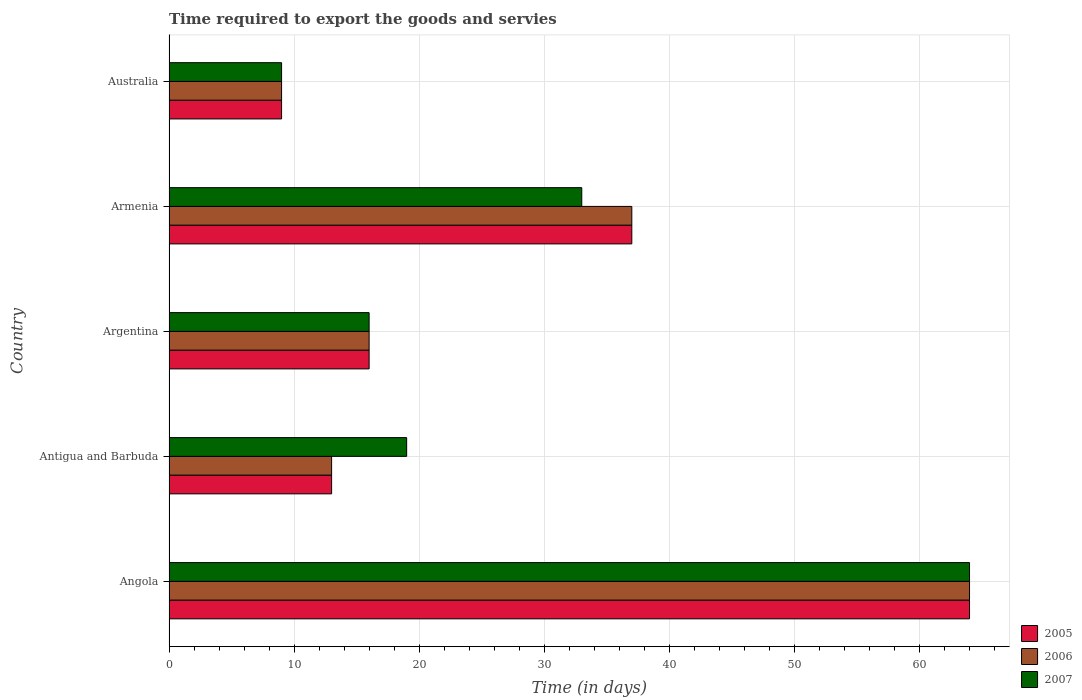How many different coloured bars are there?
Provide a succinct answer. 3. Are the number of bars per tick equal to the number of legend labels?
Give a very brief answer. Yes. Are the number of bars on each tick of the Y-axis equal?
Your response must be concise. Yes. What is the label of the 3rd group of bars from the top?
Your response must be concise. Argentina. In how many cases, is the number of bars for a given country not equal to the number of legend labels?
Offer a very short reply. 0. What is the number of days required to export the goods and services in 2007 in Australia?
Provide a succinct answer. 9. Across all countries, what is the maximum number of days required to export the goods and services in 2007?
Keep it short and to the point. 64. Across all countries, what is the minimum number of days required to export the goods and services in 2007?
Provide a short and direct response. 9. In which country was the number of days required to export the goods and services in 2007 maximum?
Provide a succinct answer. Angola. In which country was the number of days required to export the goods and services in 2006 minimum?
Ensure brevity in your answer.  Australia. What is the total number of days required to export the goods and services in 2007 in the graph?
Give a very brief answer. 141. What is the difference between the number of days required to export the goods and services in 2006 in Antigua and Barbuda and that in Armenia?
Ensure brevity in your answer.  -24. What is the difference between the number of days required to export the goods and services in 2007 in Argentina and the number of days required to export the goods and services in 2005 in Armenia?
Your response must be concise. -21. What is the average number of days required to export the goods and services in 2006 per country?
Give a very brief answer. 27.8. In how many countries, is the number of days required to export the goods and services in 2005 greater than 2 days?
Ensure brevity in your answer.  5. What is the ratio of the number of days required to export the goods and services in 2007 in Argentina to that in Armenia?
Your answer should be compact. 0.48. Is the number of days required to export the goods and services in 2005 in Angola less than that in Argentina?
Provide a short and direct response. No. Is the difference between the number of days required to export the goods and services in 2005 in Antigua and Barbuda and Australia greater than the difference between the number of days required to export the goods and services in 2007 in Antigua and Barbuda and Australia?
Provide a short and direct response. No. How many bars are there?
Your answer should be compact. 15. Are all the bars in the graph horizontal?
Offer a very short reply. Yes. How many countries are there in the graph?
Your answer should be very brief. 5. What is the difference between two consecutive major ticks on the X-axis?
Offer a very short reply. 10. Does the graph contain any zero values?
Keep it short and to the point. No. Where does the legend appear in the graph?
Offer a very short reply. Bottom right. How many legend labels are there?
Provide a succinct answer. 3. What is the title of the graph?
Provide a short and direct response. Time required to export the goods and servies. Does "2009" appear as one of the legend labels in the graph?
Provide a succinct answer. No. What is the label or title of the X-axis?
Offer a terse response. Time (in days). What is the label or title of the Y-axis?
Give a very brief answer. Country. What is the Time (in days) of 2006 in Angola?
Offer a terse response. 64. What is the Time (in days) of 2005 in Antigua and Barbuda?
Keep it short and to the point. 13. What is the Time (in days) of 2006 in Antigua and Barbuda?
Give a very brief answer. 13. What is the Time (in days) of 2007 in Antigua and Barbuda?
Your answer should be compact. 19. What is the Time (in days) of 2005 in Argentina?
Make the answer very short. 16. What is the Time (in days) of 2007 in Argentina?
Provide a short and direct response. 16. What is the Time (in days) of 2005 in Armenia?
Provide a succinct answer. 37. What is the Time (in days) in 2006 in Armenia?
Keep it short and to the point. 37. What is the Time (in days) of 2007 in Armenia?
Provide a short and direct response. 33. Across all countries, what is the maximum Time (in days) of 2007?
Ensure brevity in your answer.  64. Across all countries, what is the minimum Time (in days) of 2006?
Your response must be concise. 9. What is the total Time (in days) of 2005 in the graph?
Your answer should be compact. 139. What is the total Time (in days) in 2006 in the graph?
Provide a short and direct response. 139. What is the total Time (in days) of 2007 in the graph?
Provide a short and direct response. 141. What is the difference between the Time (in days) of 2006 in Angola and that in Antigua and Barbuda?
Your answer should be compact. 51. What is the difference between the Time (in days) of 2007 in Angola and that in Antigua and Barbuda?
Give a very brief answer. 45. What is the difference between the Time (in days) in 2006 in Angola and that in Argentina?
Offer a very short reply. 48. What is the difference between the Time (in days) in 2007 in Angola and that in Argentina?
Give a very brief answer. 48. What is the difference between the Time (in days) in 2005 in Angola and that in Armenia?
Your answer should be very brief. 27. What is the difference between the Time (in days) of 2007 in Angola and that in Armenia?
Offer a very short reply. 31. What is the difference between the Time (in days) of 2005 in Angola and that in Australia?
Make the answer very short. 55. What is the difference between the Time (in days) in 2007 in Antigua and Barbuda and that in Argentina?
Make the answer very short. 3. What is the difference between the Time (in days) of 2005 in Antigua and Barbuda and that in Armenia?
Give a very brief answer. -24. What is the difference between the Time (in days) in 2007 in Antigua and Barbuda and that in Armenia?
Keep it short and to the point. -14. What is the difference between the Time (in days) in 2007 in Antigua and Barbuda and that in Australia?
Offer a terse response. 10. What is the difference between the Time (in days) of 2005 in Argentina and that in Armenia?
Provide a short and direct response. -21. What is the difference between the Time (in days) of 2005 in Argentina and that in Australia?
Offer a very short reply. 7. What is the difference between the Time (in days) of 2006 in Argentina and that in Australia?
Keep it short and to the point. 7. What is the difference between the Time (in days) of 2007 in Argentina and that in Australia?
Provide a succinct answer. 7. What is the difference between the Time (in days) in 2006 in Armenia and that in Australia?
Ensure brevity in your answer.  28. What is the difference between the Time (in days) of 2005 in Angola and the Time (in days) of 2007 in Antigua and Barbuda?
Your response must be concise. 45. What is the difference between the Time (in days) in 2006 in Angola and the Time (in days) in 2007 in Antigua and Barbuda?
Your answer should be very brief. 45. What is the difference between the Time (in days) in 2005 in Angola and the Time (in days) in 2006 in Argentina?
Keep it short and to the point. 48. What is the difference between the Time (in days) of 2005 in Angola and the Time (in days) of 2006 in Armenia?
Give a very brief answer. 27. What is the difference between the Time (in days) of 2005 in Angola and the Time (in days) of 2007 in Armenia?
Offer a terse response. 31. What is the difference between the Time (in days) in 2006 in Angola and the Time (in days) in 2007 in Armenia?
Provide a short and direct response. 31. What is the difference between the Time (in days) in 2005 in Antigua and Barbuda and the Time (in days) in 2006 in Argentina?
Keep it short and to the point. -3. What is the difference between the Time (in days) of 2006 in Antigua and Barbuda and the Time (in days) of 2007 in Argentina?
Keep it short and to the point. -3. What is the difference between the Time (in days) in 2005 in Antigua and Barbuda and the Time (in days) in 2006 in Armenia?
Keep it short and to the point. -24. What is the difference between the Time (in days) in 2005 in Antigua and Barbuda and the Time (in days) in 2007 in Armenia?
Your response must be concise. -20. What is the difference between the Time (in days) in 2006 in Argentina and the Time (in days) in 2007 in Armenia?
Give a very brief answer. -17. What is the difference between the Time (in days) in 2005 in Argentina and the Time (in days) in 2006 in Australia?
Keep it short and to the point. 7. What is the difference between the Time (in days) in 2005 in Argentina and the Time (in days) in 2007 in Australia?
Your response must be concise. 7. What is the average Time (in days) of 2005 per country?
Your answer should be compact. 27.8. What is the average Time (in days) of 2006 per country?
Give a very brief answer. 27.8. What is the average Time (in days) in 2007 per country?
Give a very brief answer. 28.2. What is the difference between the Time (in days) of 2005 and Time (in days) of 2007 in Angola?
Offer a very short reply. 0. What is the difference between the Time (in days) in 2005 and Time (in days) in 2006 in Antigua and Barbuda?
Give a very brief answer. 0. What is the difference between the Time (in days) in 2005 and Time (in days) in 2007 in Antigua and Barbuda?
Your answer should be compact. -6. What is the difference between the Time (in days) in 2006 and Time (in days) in 2007 in Argentina?
Ensure brevity in your answer.  0. What is the difference between the Time (in days) of 2005 and Time (in days) of 2006 in Armenia?
Your answer should be compact. 0. What is the difference between the Time (in days) in 2005 and Time (in days) in 2007 in Armenia?
Ensure brevity in your answer.  4. What is the difference between the Time (in days) of 2005 and Time (in days) of 2007 in Australia?
Keep it short and to the point. 0. What is the difference between the Time (in days) in 2006 and Time (in days) in 2007 in Australia?
Keep it short and to the point. 0. What is the ratio of the Time (in days) in 2005 in Angola to that in Antigua and Barbuda?
Provide a succinct answer. 4.92. What is the ratio of the Time (in days) of 2006 in Angola to that in Antigua and Barbuda?
Give a very brief answer. 4.92. What is the ratio of the Time (in days) in 2007 in Angola to that in Antigua and Barbuda?
Keep it short and to the point. 3.37. What is the ratio of the Time (in days) of 2005 in Angola to that in Armenia?
Your answer should be compact. 1.73. What is the ratio of the Time (in days) of 2006 in Angola to that in Armenia?
Your response must be concise. 1.73. What is the ratio of the Time (in days) of 2007 in Angola to that in Armenia?
Your response must be concise. 1.94. What is the ratio of the Time (in days) in 2005 in Angola to that in Australia?
Make the answer very short. 7.11. What is the ratio of the Time (in days) in 2006 in Angola to that in Australia?
Your answer should be very brief. 7.11. What is the ratio of the Time (in days) of 2007 in Angola to that in Australia?
Keep it short and to the point. 7.11. What is the ratio of the Time (in days) in 2005 in Antigua and Barbuda to that in Argentina?
Offer a very short reply. 0.81. What is the ratio of the Time (in days) of 2006 in Antigua and Barbuda to that in Argentina?
Provide a short and direct response. 0.81. What is the ratio of the Time (in days) of 2007 in Antigua and Barbuda to that in Argentina?
Provide a short and direct response. 1.19. What is the ratio of the Time (in days) in 2005 in Antigua and Barbuda to that in Armenia?
Your answer should be very brief. 0.35. What is the ratio of the Time (in days) of 2006 in Antigua and Barbuda to that in Armenia?
Your answer should be very brief. 0.35. What is the ratio of the Time (in days) of 2007 in Antigua and Barbuda to that in Armenia?
Make the answer very short. 0.58. What is the ratio of the Time (in days) of 2005 in Antigua and Barbuda to that in Australia?
Make the answer very short. 1.44. What is the ratio of the Time (in days) in 2006 in Antigua and Barbuda to that in Australia?
Provide a succinct answer. 1.44. What is the ratio of the Time (in days) of 2007 in Antigua and Barbuda to that in Australia?
Provide a short and direct response. 2.11. What is the ratio of the Time (in days) of 2005 in Argentina to that in Armenia?
Your response must be concise. 0.43. What is the ratio of the Time (in days) in 2006 in Argentina to that in Armenia?
Provide a short and direct response. 0.43. What is the ratio of the Time (in days) in 2007 in Argentina to that in Armenia?
Make the answer very short. 0.48. What is the ratio of the Time (in days) in 2005 in Argentina to that in Australia?
Offer a terse response. 1.78. What is the ratio of the Time (in days) of 2006 in Argentina to that in Australia?
Make the answer very short. 1.78. What is the ratio of the Time (in days) of 2007 in Argentina to that in Australia?
Provide a short and direct response. 1.78. What is the ratio of the Time (in days) of 2005 in Armenia to that in Australia?
Ensure brevity in your answer.  4.11. What is the ratio of the Time (in days) in 2006 in Armenia to that in Australia?
Keep it short and to the point. 4.11. What is the ratio of the Time (in days) in 2007 in Armenia to that in Australia?
Your response must be concise. 3.67. What is the difference between the highest and the second highest Time (in days) of 2005?
Your answer should be compact. 27. What is the difference between the highest and the lowest Time (in days) of 2007?
Keep it short and to the point. 55. 